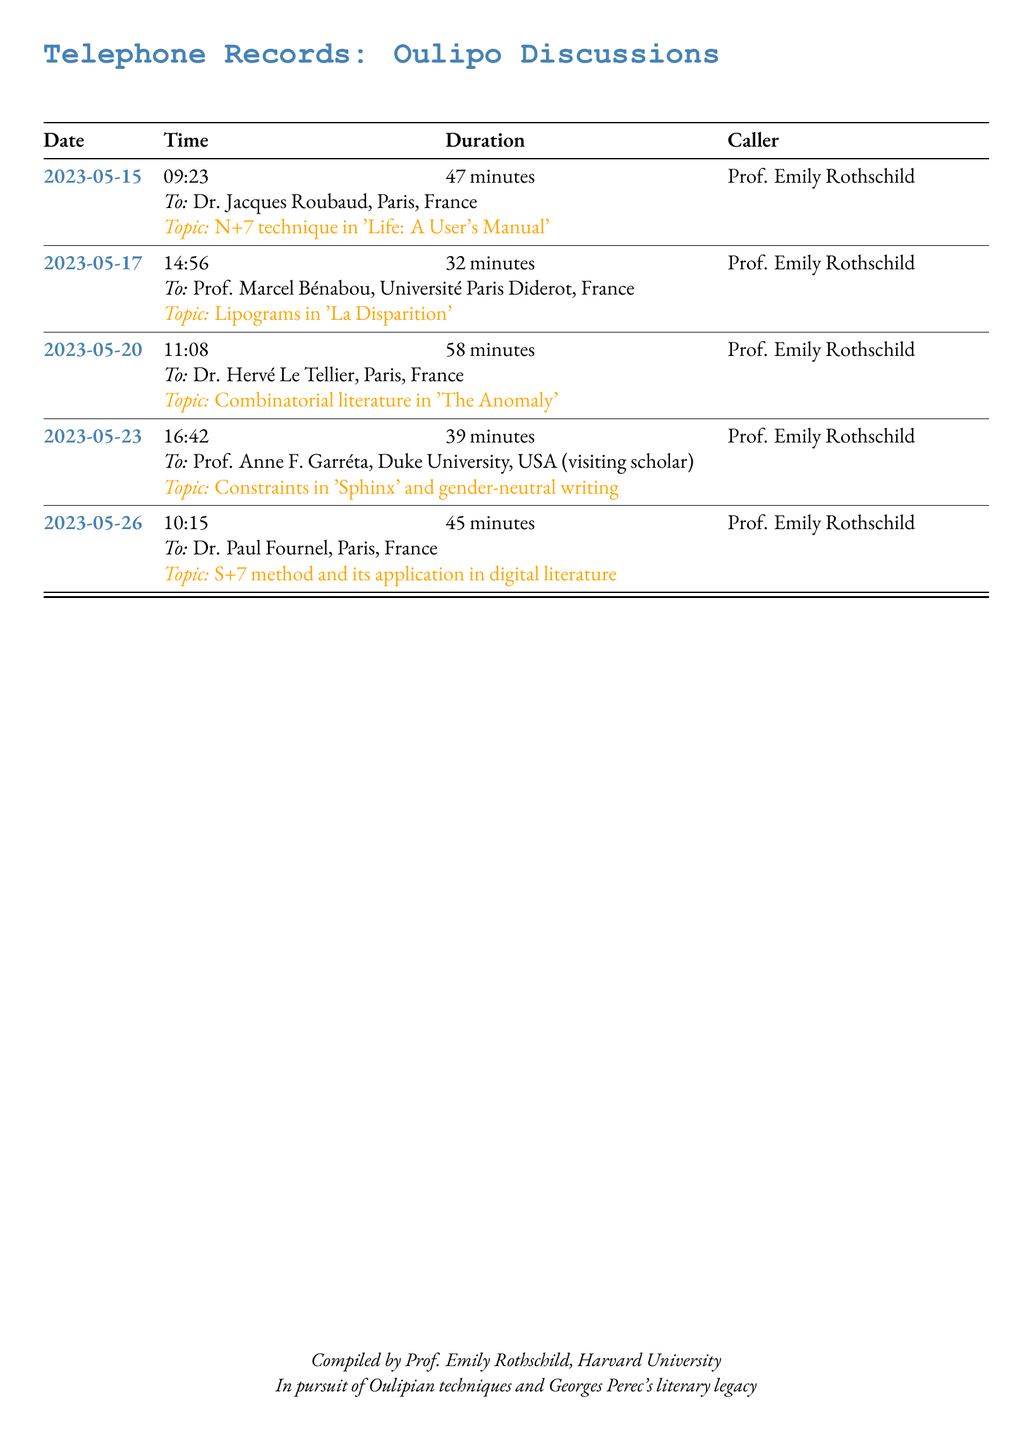What is the duration of the call on May 20? The duration for the call on May 20th is specified in the document as 58 minutes.
Answer: 58 minutes Who did Prof. Emily Rothschild call on May 15? The document states that on May 15th, Prof. Emily Rothschild called Dr. Jacques Roubaud.
Answer: Dr. Jacques Roubaud What literary technique was discussed during the call with Prof. Marcel Bénabou? The technique discussed with Prof. Marcel Bénabou was lipograms in 'La Disparition', as mentioned in the document.
Answer: Lipograms How many calls took place in May 2023? The document lists five calls that occurred in May 2023, providing their details.
Answer: 5 What publication was mentioned in the call with Dr. Hervé Le Tellier? The document mentions 'The Anomaly' in relation to the call with Dr. Hervé Le Tellier.
Answer: The Anomaly Which university did Prof. Anne F. Garréta represent? The document indicates that Prof. Anne F. Garréta was from Duke University, USA, as a visiting scholar.
Answer: Duke University What is the primary focus of the telephone records? The records center around discussions of Oulipo techniques and Georges Perec's literary legacy.
Answer: Oulipo techniques What was the primary topic discussed on May 26? The document specifies that the S+7 method and its application in digital literature were discussed on May 26.
Answer: S+7 method What was Prof. Emily Rothschild's role in compiling this document? The document states that she compiled the records highlighting her focus on Oulipian techniques.
Answer: Compiled by Prof. Emily Rothschild 